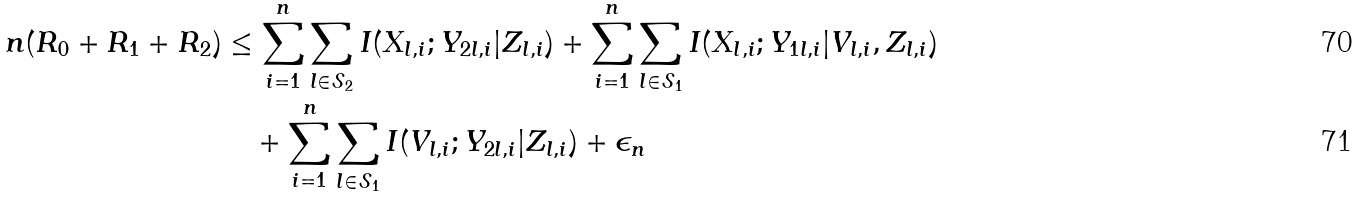Convert formula to latex. <formula><loc_0><loc_0><loc_500><loc_500>n ( R _ { 0 } + R _ { 1 } + R _ { 2 } ) & \leq \sum _ { i = 1 } ^ { n } \sum _ { l \in \mathcal { S } _ { 2 } } I ( X _ { l , i } ; Y _ { 2 l , i } | Z _ { l , i } ) + \sum _ { i = 1 } ^ { n } \sum _ { l \in \mathcal { S } _ { 1 } } I ( X _ { l , i } ; Y _ { 1 l , i } | V _ { l , i } , Z _ { l , i } ) \\ & \quad + \sum _ { i = 1 } ^ { n } \sum _ { l \in \mathcal { S } _ { 1 } } I ( V _ { l , i } ; Y _ { 2 l , i } | Z _ { l , i } ) + \epsilon _ { n }</formula> 